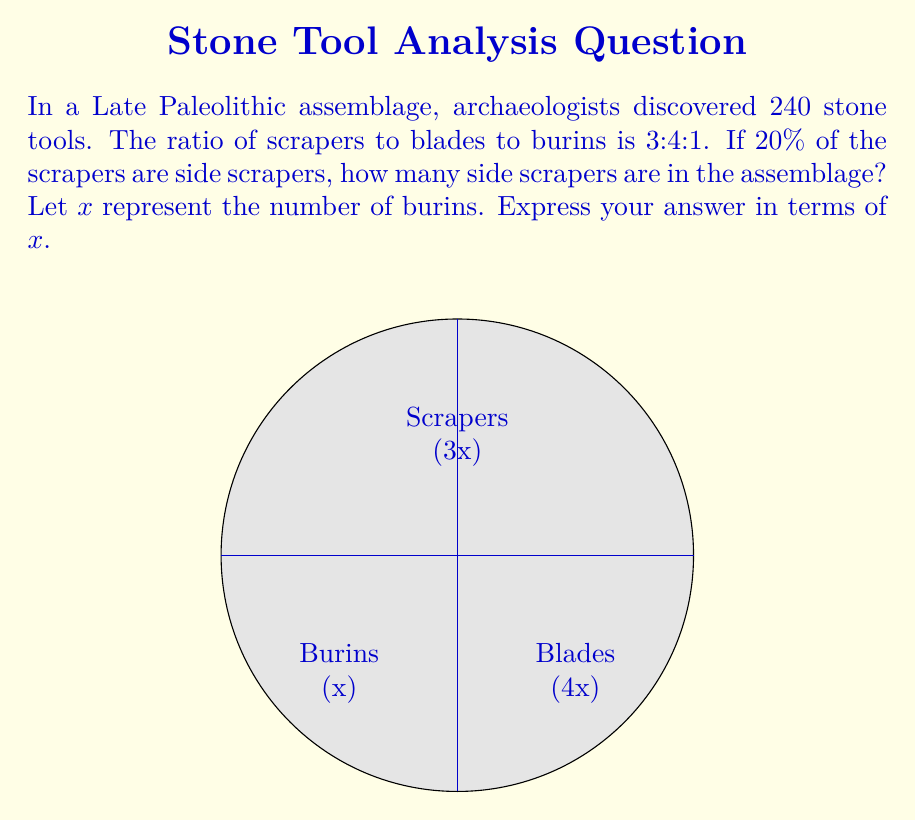Can you solve this math problem? Let's approach this step-by-step:

1) First, we need to find the total number of parts in the ratio:
   $3 + 4 + 1 = 8$ parts

2) If $x$ represents the number of burins, then:
   Scrapers = $3x$
   Blades = $4x$
   Burins = $x$

3) The total number of tools is 240, so we can set up the equation:
   $3x + 4x + x = 240$
   $8x = 240$

4) We don't need to solve for $x$, as we're asked to express the answer in terms of $x$.

5) We know that scrapers account for $3x$ of the tools.

6) The question states that 20% of the scrapers are side scrapers.
   To calculate 20% of $3x$:
   
   $$\frac{20}{100} \cdot 3x = 0.2 \cdot 3x = 0.6x$$

Therefore, the number of side scrapers is $0.6x$.
Answer: $0.6x$ 